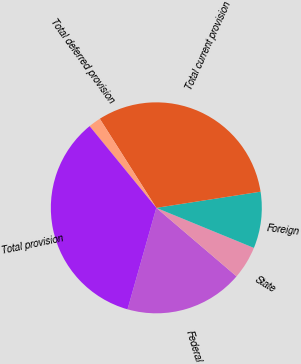<chart> <loc_0><loc_0><loc_500><loc_500><pie_chart><fcel>Federal<fcel>State<fcel>Foreign<fcel>Total current provision<fcel>Total deferred provision<fcel>Total provision<nl><fcel>18.15%<fcel>5.05%<fcel>8.65%<fcel>31.55%<fcel>1.9%<fcel>34.7%<nl></chart> 